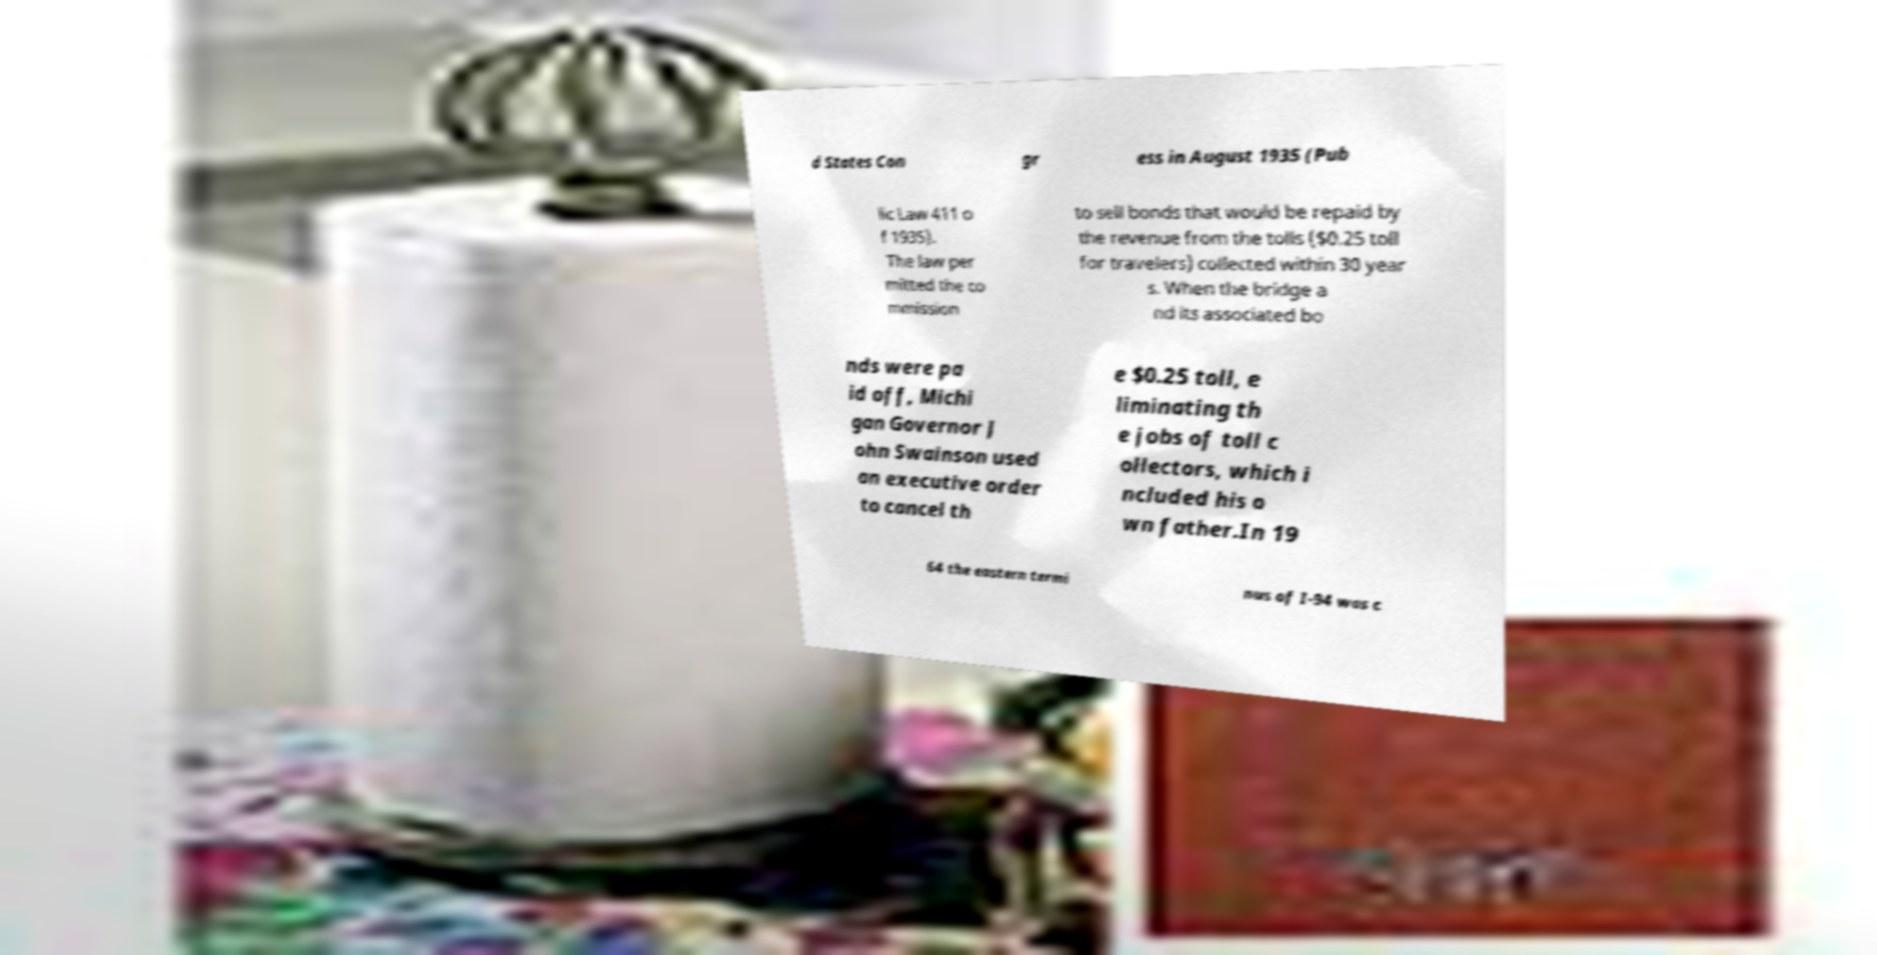Can you accurately transcribe the text from the provided image for me? d States Con gr ess in August 1935 (Pub lic Law 411 o f 1935). The law per mitted the co mmission to sell bonds that would be repaid by the revenue from the tolls ($0.25 toll for travelers) collected within 30 year s. When the bridge a nd its associated bo nds were pa id off, Michi gan Governor J ohn Swainson used an executive order to cancel th e $0.25 toll, e liminating th e jobs of toll c ollectors, which i ncluded his o wn father.In 19 64 the eastern termi nus of I-94 was c 